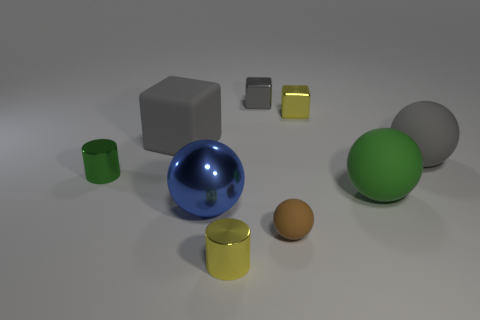How many things are either gray matte spheres or yellow cylinders? In the image, I can identify one gray matte sphere and one yellow cylinder, making a total of two objects that match the criteria you specified. 